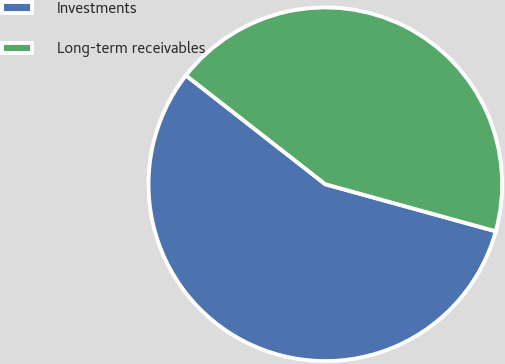<chart> <loc_0><loc_0><loc_500><loc_500><pie_chart><fcel>Investments<fcel>Long-term receivables<nl><fcel>56.27%<fcel>43.73%<nl></chart> 